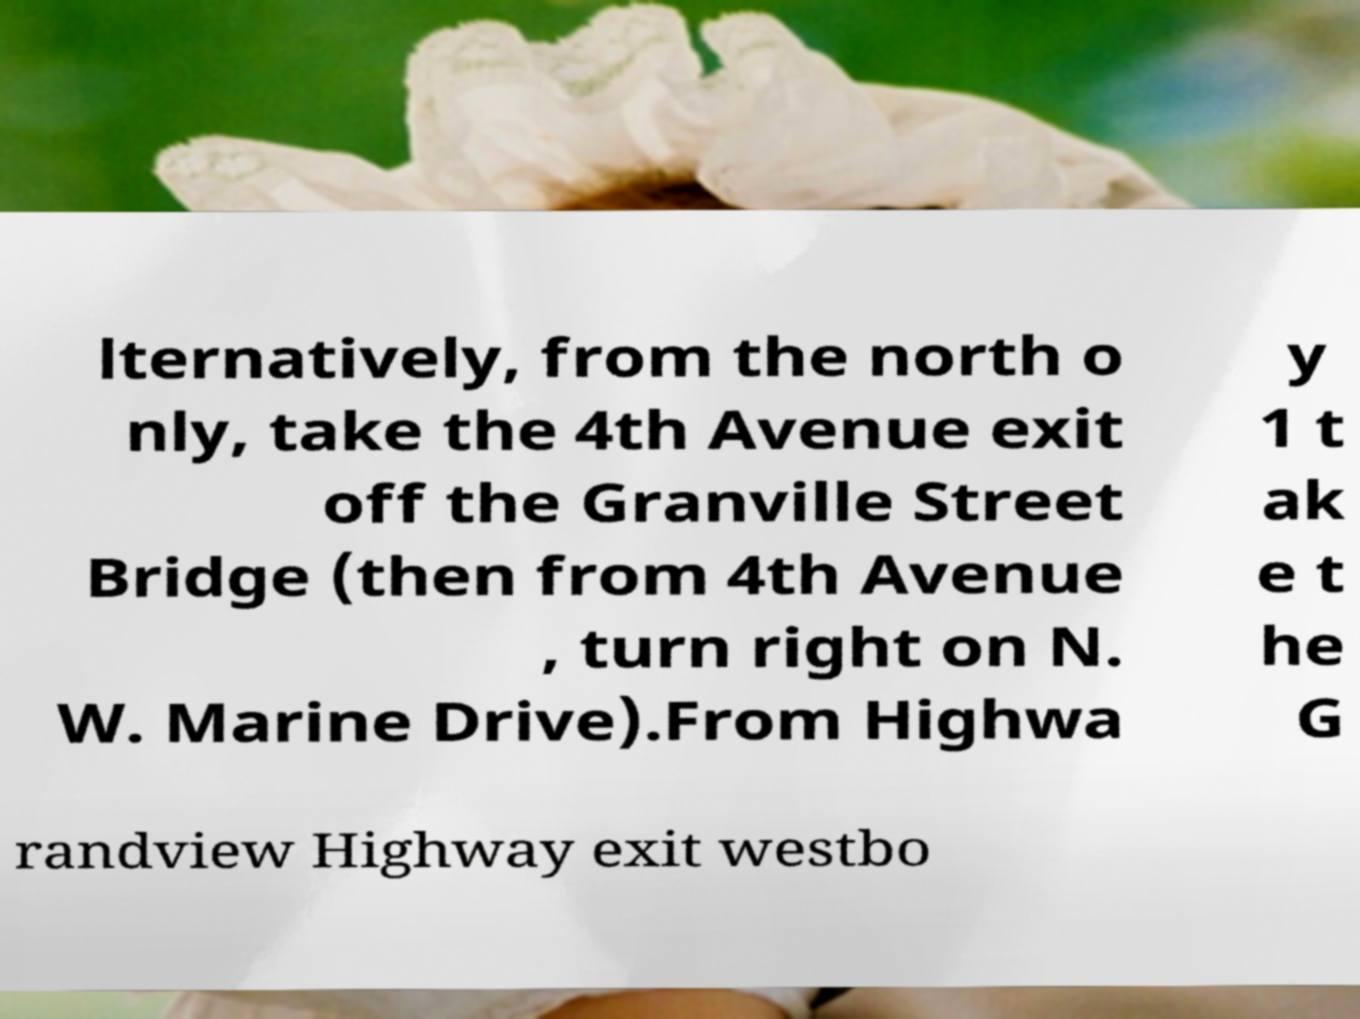Please identify and transcribe the text found in this image. lternatively, from the north o nly, take the 4th Avenue exit off the Granville Street Bridge (then from 4th Avenue , turn right on N. W. Marine Drive).From Highwa y 1 t ak e t he G randview Highway exit westbo 